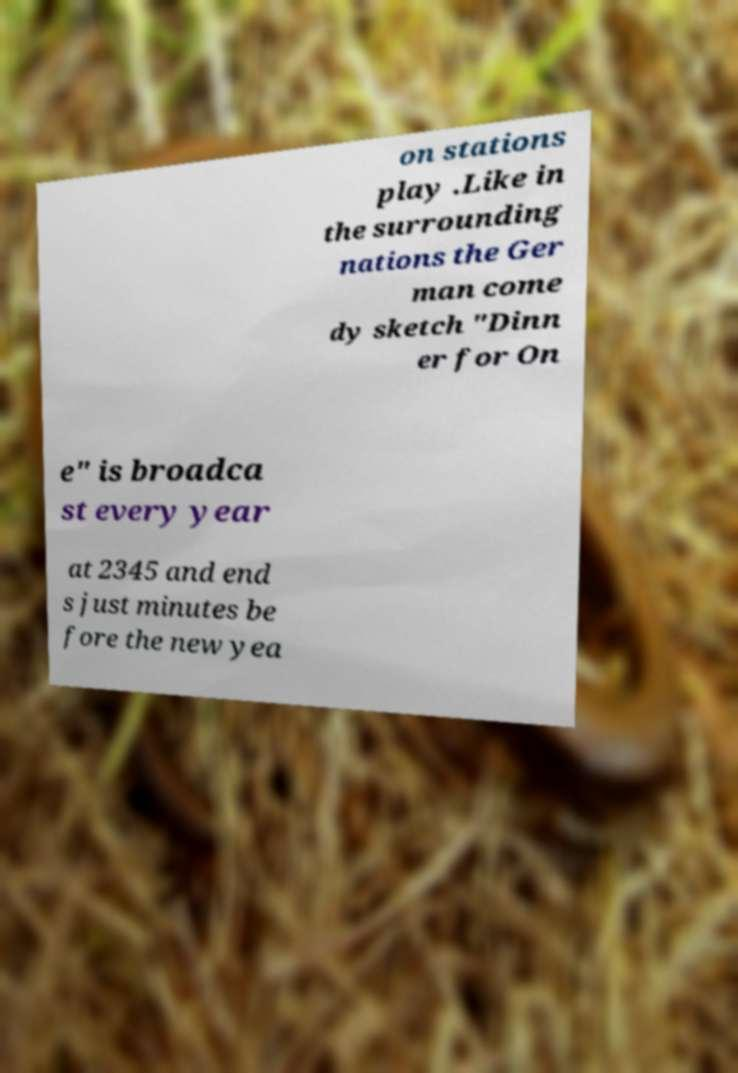Could you extract and type out the text from this image? on stations play .Like in the surrounding nations the Ger man come dy sketch "Dinn er for On e" is broadca st every year at 2345 and end s just minutes be fore the new yea 